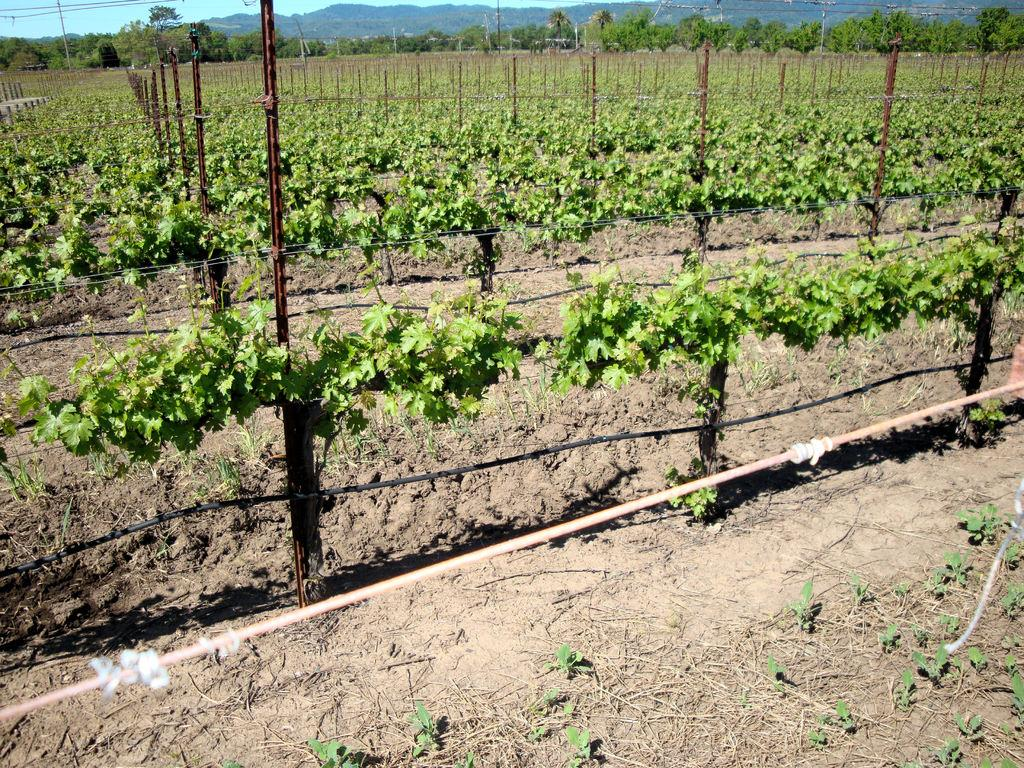What type of landscape is depicted in the image? The image features farmlands. What can be seen growing in the farmlands? There are plants in the image. What structures are present in the farmlands? There are poles and fencing in the image. What can be seen in the background of the image? There are trees and mountains in the background of the image. What type of list can be seen hanging on the poles in the image? There is no list present in the image; the poles are part of the fencing and do not have any lists attached to them. 